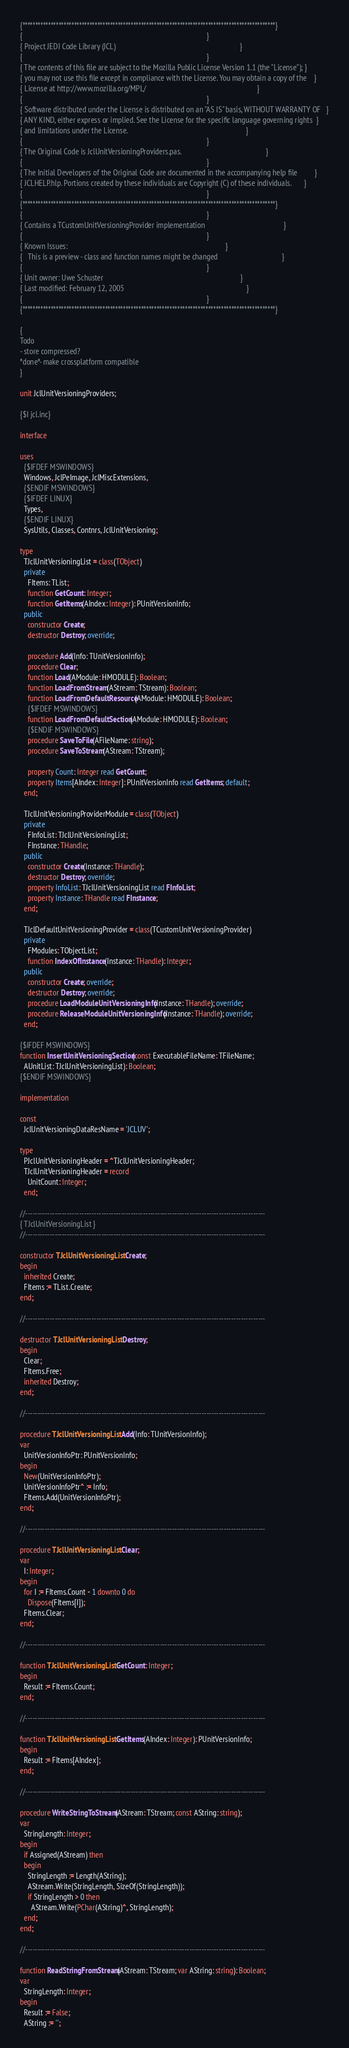<code> <loc_0><loc_0><loc_500><loc_500><_Pascal_>{**************************************************************************************************}
{                                                                                                  }
{ Project JEDI Code Library (JCL)                                                                  }
{                                                                                                  }
{ The contents of this file are subject to the Mozilla Public License Version 1.1 (the "License"); }
{ you may not use this file except in compliance with the License. You may obtain a copy of the    }
{ License at http://www.mozilla.org/MPL/                                                           }
{                                                                                                  }
{ Software distributed under the License is distributed on an "AS IS" basis, WITHOUT WARRANTY OF   }
{ ANY KIND, either express or implied. See the License for the specific language governing rights  }
{ and limitations under the License.                                                               }
{                                                                                                  }
{ The Original Code is JclUnitVersioningProviders.pas.                                             }
{                                                                                                  }
{ The Initial Developers of the Original Code are documented in the accompanying help file         }
{ JCLHELP.hlp. Portions created by these individuals are Copyright (C) of these individuals.       }
{                                                                                                  }
{**************************************************************************************************}
{                                                                                                  }
{ Contains a TCustomUnitVersioningProvider implementation                                          }
{                                                                                                  }
{ Known Issues:                                                                                    }
{   This is a preview - class and function names might be changed                                  }
{                                                                                                  }
{ Unit owner: Uwe Schuster                                                                         }
{ Last modified: February 12, 2005                                                                 }
{                                                                                                  }
{**************************************************************************************************}

{
Todo
- store compressed?
*done*- make crossplatform compatible
}

unit JclUnitVersioningProviders;

{$I jcl.inc}

interface

uses
  {$IFDEF MSWINDOWS}
  Windows, JclPeImage, JclMiscExtensions,
  {$ENDIF MSWINDOWS}
  {$IFDEF LINUX}
  Types,
  {$ENDIF LINUX}
  SysUtils, Classes, Contnrs, JclUnitVersioning;

type
  TJclUnitVersioningList = class(TObject)
  private
    FItems: TList;
    function GetCount: Integer;
    function GetItems(AIndex: Integer): PUnitVersionInfo;
  public
    constructor Create;
    destructor Destroy; override;

    procedure Add(Info: TUnitVersionInfo);
    procedure Clear;
    function Load(AModule: HMODULE): Boolean;
    function LoadFromStream(AStream: TStream): Boolean;
    function LoadFromDefaultResource(AModule: HMODULE): Boolean;
    {$IFDEF MSWINDOWS}
    function LoadFromDefaultSection(AModule: HMODULE): Boolean;
    {$ENDIF MSWINDOWS}
    procedure SaveToFile(AFileName: string);
    procedure SaveToStream(AStream: TStream);

    property Count: Integer read GetCount;
    property Items[AIndex: Integer]: PUnitVersionInfo read GetItems; default;
  end;

  TJclUnitVersioningProviderModule = class(TObject)
  private
    FInfoList: TJclUnitVersioningList;
    FInstance: THandle;
  public
    constructor Create(Instance: THandle);
    destructor Destroy; override;
    property InfoList: TJclUnitVersioningList read FInfoList;
    property Instance: THandle read FInstance;
  end;

  TJclDefaultUnitVersioningProvider = class(TCustomUnitVersioningProvider)
  private
    FModules: TObjectList;
    function IndexOfInstance(Instance: THandle): Integer;
  public
    constructor Create; override;
    destructor Destroy; override;
    procedure LoadModuleUnitVersioningInfo(Instance: THandle); override;
    procedure ReleaseModuleUnitVersioningInfo(Instance: THandle); override;
  end;

{$IFDEF MSWINDOWS}
function InsertUnitVersioningSection(const ExecutableFileName: TFileName;
  AUnitList: TJclUnitVersioningList): Boolean;
{$ENDIF MSWINDOWS}

implementation

const
  JclUnitVersioningDataResName = 'JCLUV';

type
  PJclUnitVersioningHeader = ^TJclUnitVersioningHeader;
  TJclUnitVersioningHeader = record
    UnitCount: Integer;
  end;

//--------------------------------------------------------------------------------------------------
{ TJclUnitVersioningList }
//--------------------------------------------------------------------------------------------------

constructor TJclUnitVersioningList.Create;
begin
  inherited Create;
  FItems := TList.Create;
end;

//--------------------------------------------------------------------------------------------------

destructor TJclUnitVersioningList.Destroy;
begin
  Clear;
  FItems.Free;
  inherited Destroy;
end;

//--------------------------------------------------------------------------------------------------

procedure TJclUnitVersioningList.Add(Info: TUnitVersionInfo);
var
  UnitVersionInfoPtr: PUnitVersionInfo;
begin
  New(UnitVersionInfoPtr);
  UnitVersionInfoPtr^ := Info;
  FItems.Add(UnitVersionInfoPtr);
end;

//--------------------------------------------------------------------------------------------------

procedure TJclUnitVersioningList.Clear;
var
  I: Integer;
begin
  for I := FItems.Count - 1 downto 0 do
    Dispose(FItems[I]);
  FItems.Clear;
end;

//--------------------------------------------------------------------------------------------------

function TJclUnitVersioningList.GetCount: Integer;
begin
  Result := FItems.Count;
end;

//--------------------------------------------------------------------------------------------------

function TJclUnitVersioningList.GetItems(AIndex: Integer): PUnitVersionInfo;
begin
  Result := FItems[AIndex];
end;

//--------------------------------------------------------------------------------------------------

procedure WriteStringToStream(AStream: TStream; const AString: string);
var
  StringLength: Integer;
begin
  if Assigned(AStream) then
  begin
    StringLength := Length(AString);
    AStream.Write(StringLength, SizeOf(StringLength));
    if StringLength > 0 then
      AStream.Write(PChar(AString)^, StringLength);
  end;
end;

//--------------------------------------------------------------------------------------------------

function ReadStringFromStream(AStream: TStream; var AString: string): Boolean;
var
  StringLength: Integer;
begin
  Result := False;
  AString := '';</code> 